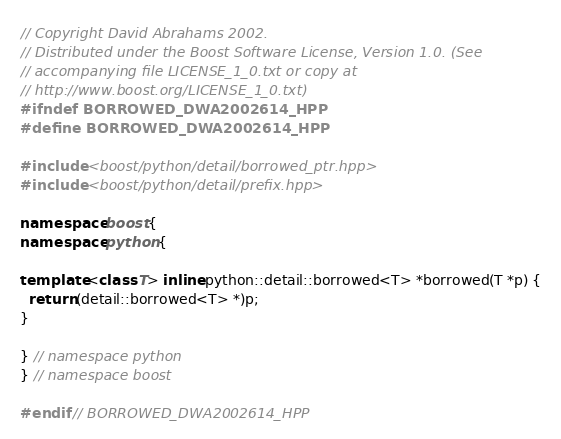Convert code to text. <code><loc_0><loc_0><loc_500><loc_500><_C++_>// Copyright David Abrahams 2002.
// Distributed under the Boost Software License, Version 1.0. (See
// accompanying file LICENSE_1_0.txt or copy at
// http://www.boost.org/LICENSE_1_0.txt)
#ifndef BORROWED_DWA2002614_HPP
#define BORROWED_DWA2002614_HPP

#include <boost/python/detail/borrowed_ptr.hpp>
#include <boost/python/detail/prefix.hpp>

namespace boost {
namespace python {

template <class T> inline python::detail::borrowed<T> *borrowed(T *p) {
  return (detail::borrowed<T> *)p;
}

} // namespace python
} // namespace boost

#endif // BORROWED_DWA2002614_HPP
</code> 